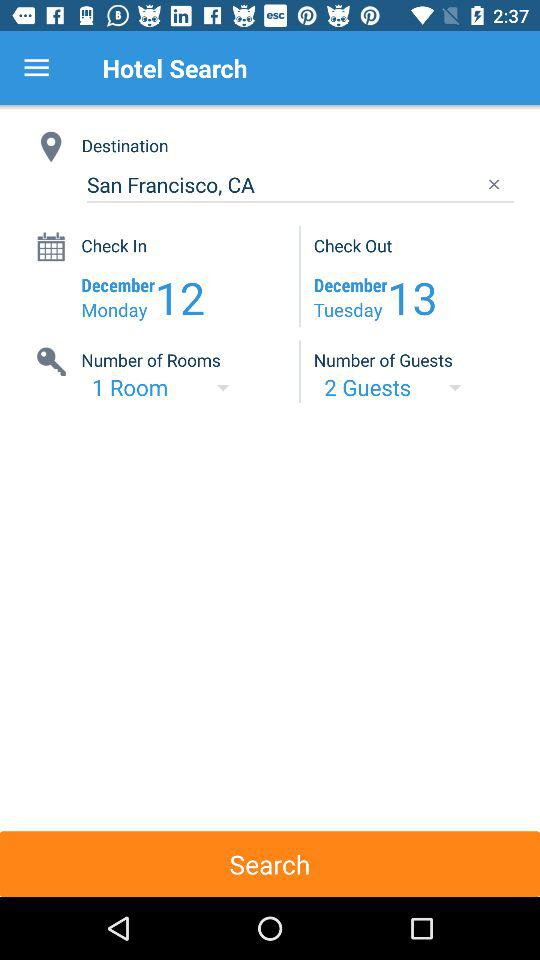What is the destination? The destination is San Francisco, California. 